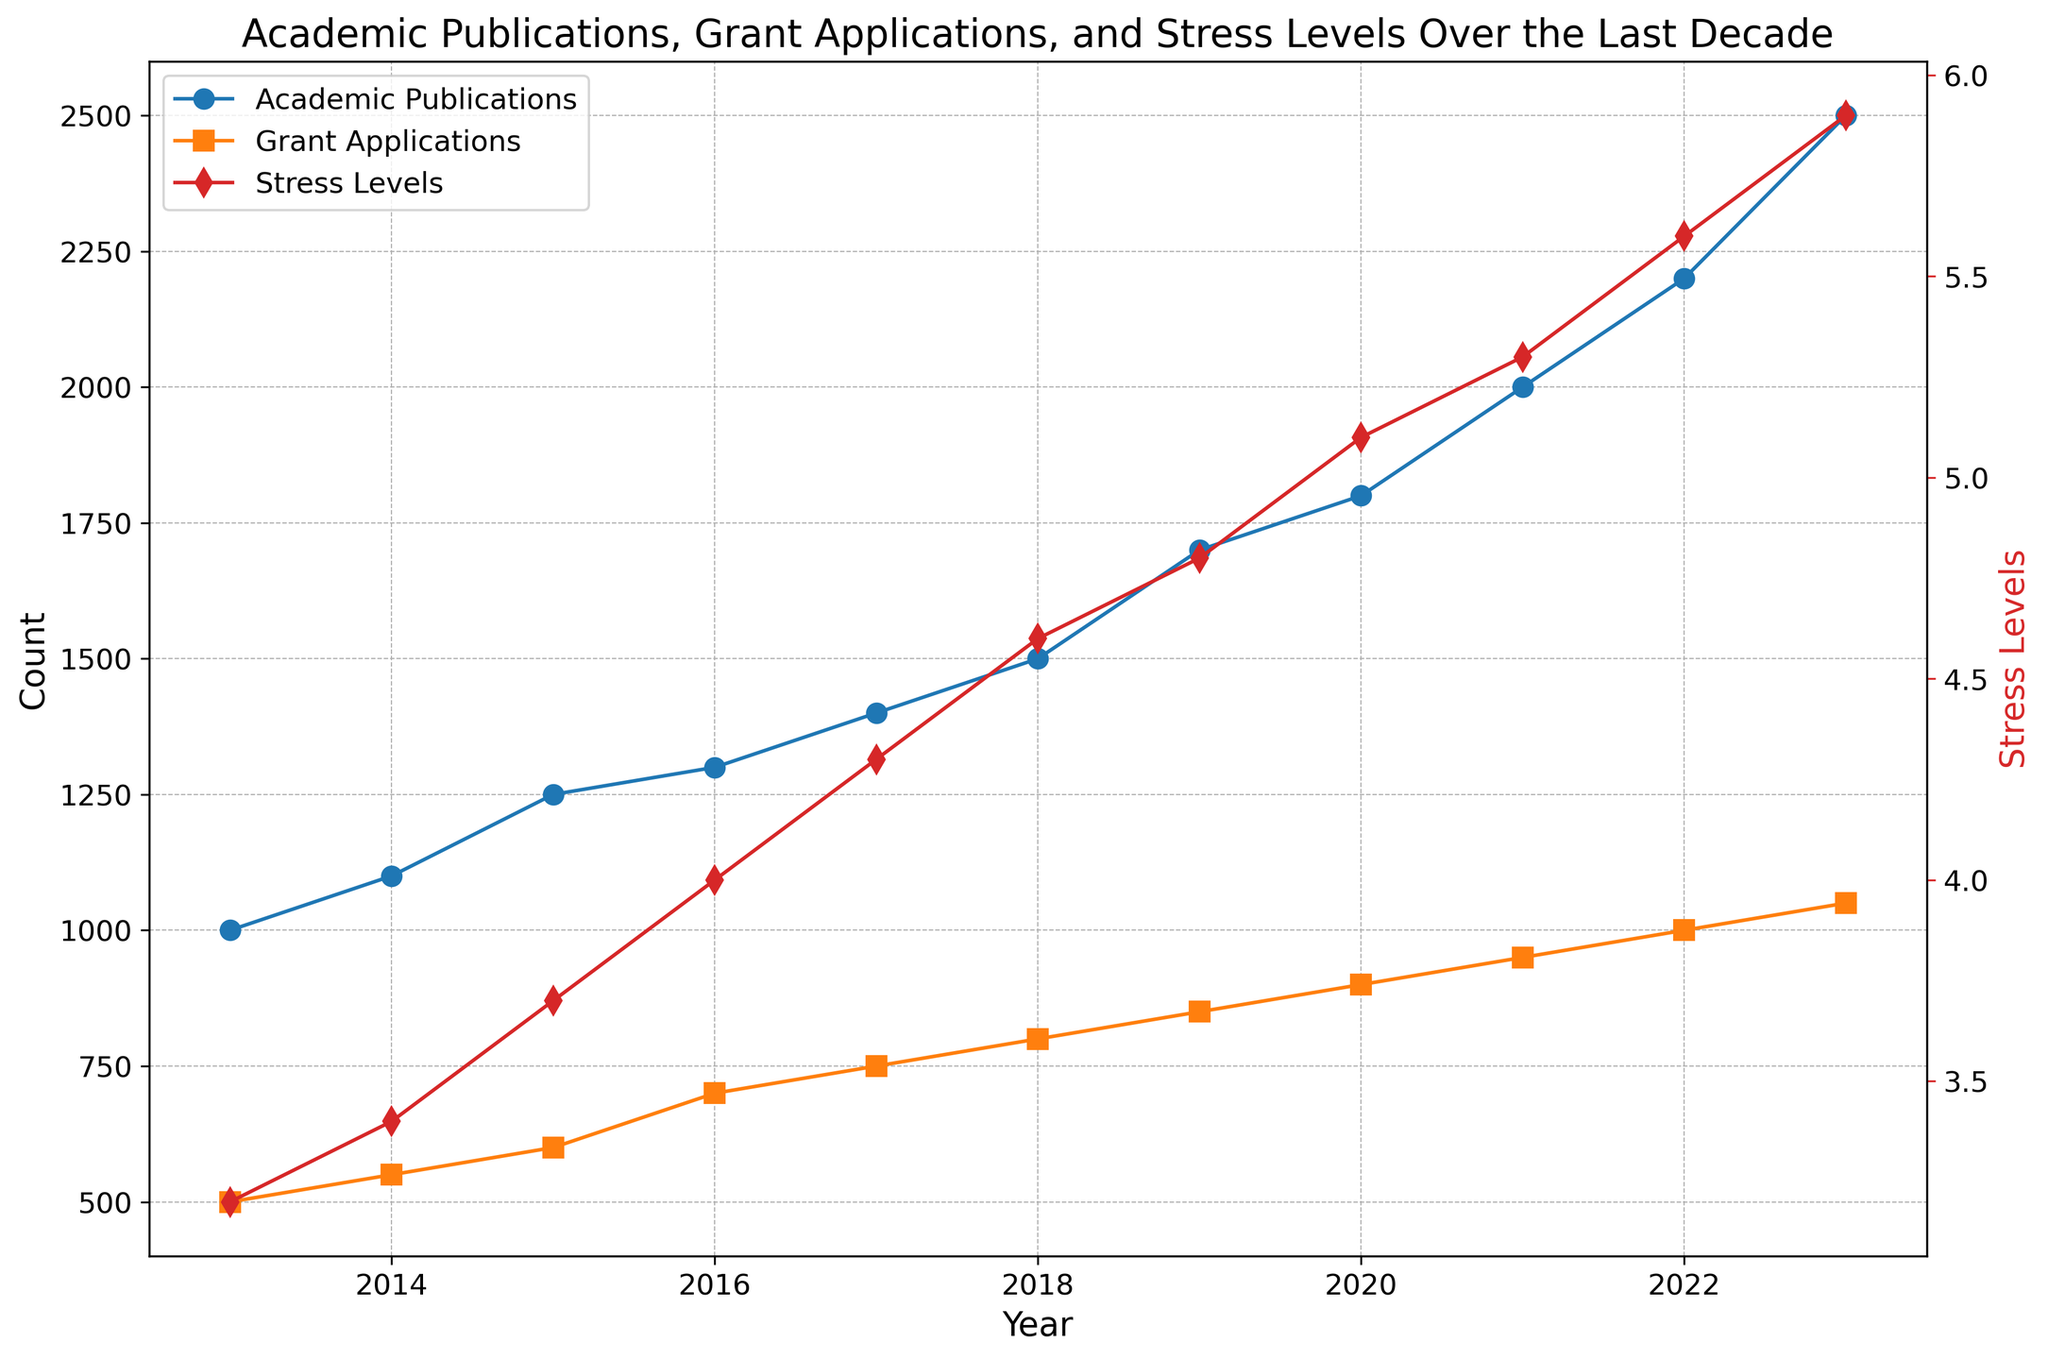What year had the highest number of academic publications? To find this, look at the blue line representing Academic Publications and identify the peak point. The highest value on the chart is 2500 publications in the year 2023.
Answer: 2023 Which came first, the rise in stress levels above 4.5 or grant applications exceeding 800? Compare the red line (Stress Levels) and the orange line (Grant Applications) at the time they cross these thresholds. Stress levels exceed 4.5 in 2018, while grant applications exceed 800 the same year. Therefore, they happen simultaneously in 2018.
Answer: 2018 What is the difference in academic publications between 2013 and 2023? Calculate the difference between the number of academic publications in 2023 and 2013 using the blue line data: 2500 (2023) - 1000 (2013) = 1500.
Answer: 1500 By how much did stress levels increase from 2014 to 2019? Subtract the stress level in 2014 from that in 2019 using the red line data: 4.8 (2019) - 3.4 (2014) = 1.4.
Answer: 1.4 How many years did it take for grant applications to increase from 500 to 1000? Identify the years when grant applications were around 500 and 1000 using the orange line: 500 in 2013 and 1000 in 2022. The difference is 2022 - 2013 = 9 years.
Answer: 9 years What is the average number of grant applications between 2015 and 2019? Sum the number of grant applications from 2015 to 2019 and divide by the count of these years. Sum: 600 (2015) + 700 (2016) + 750 (2017) + 800 (2018) + 850 (2019) = 3700. Average: 3700 / 5 = 740.
Answer: 740 Which year saw the sharpest increase in stress levels? Look for the year-to-year differences in the red line and identify the largest jump. Between 2022 to 2023, stress levels increase from 5.6 to 5.9, a 0.3 jump.
Answer: 2023 What is the correlation between the number of academic publications and stress levels over the decade? Observe the trend and alignment of the blue and red lines over the years. As academic publications increase noticeably, stress levels also follow a similar upward trend, indicating a likely positive correlation between them.
Answer: Positive correlation Are there any years where academic publications decreased compared to the previous year? Look for any downward trend in the blue line between consecutive years. The blue line showing academic publications consistently increases every year without any decrease.
Answer: No 